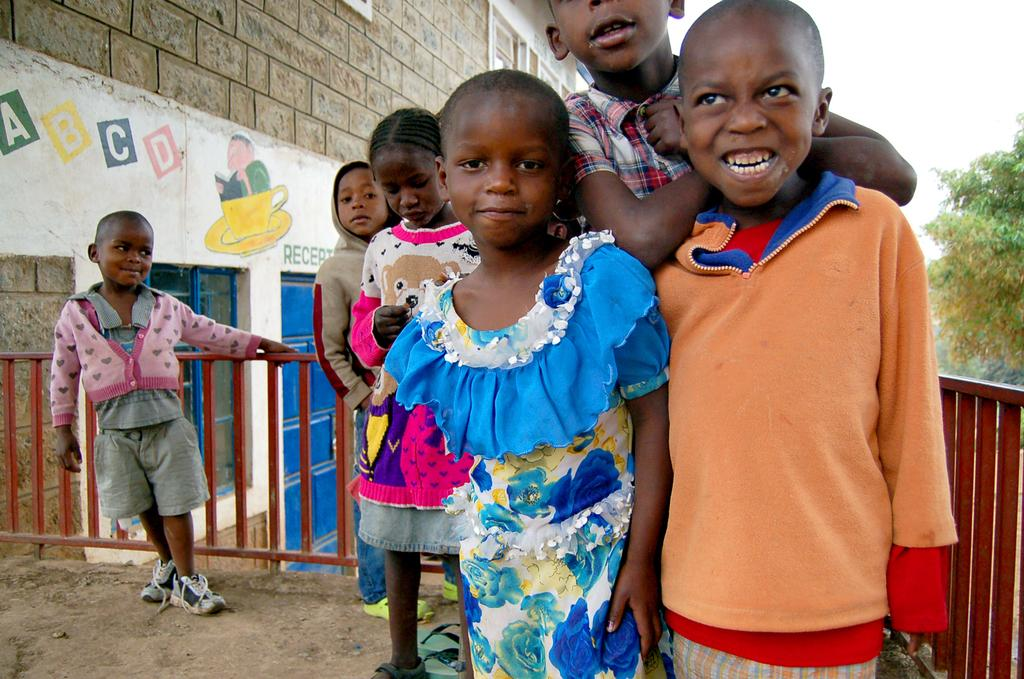What can be seen in the image involving children? There are kids standing in the image. What is located beside the kids? There is a fence beside the kids. What structure is visible in the left corner of the image? There is a building in the left corner of the image. What type of plant or vegetation is in the right corner of the image? There is a tree in the right corner of the image. What type of joke can be seen being told by the duck in the image? There is no duck present in the image, so no joke can be observed. What type of yoke is being used by the kids in the image? There is no yoke present in the image, and the kids are not using any such object. 